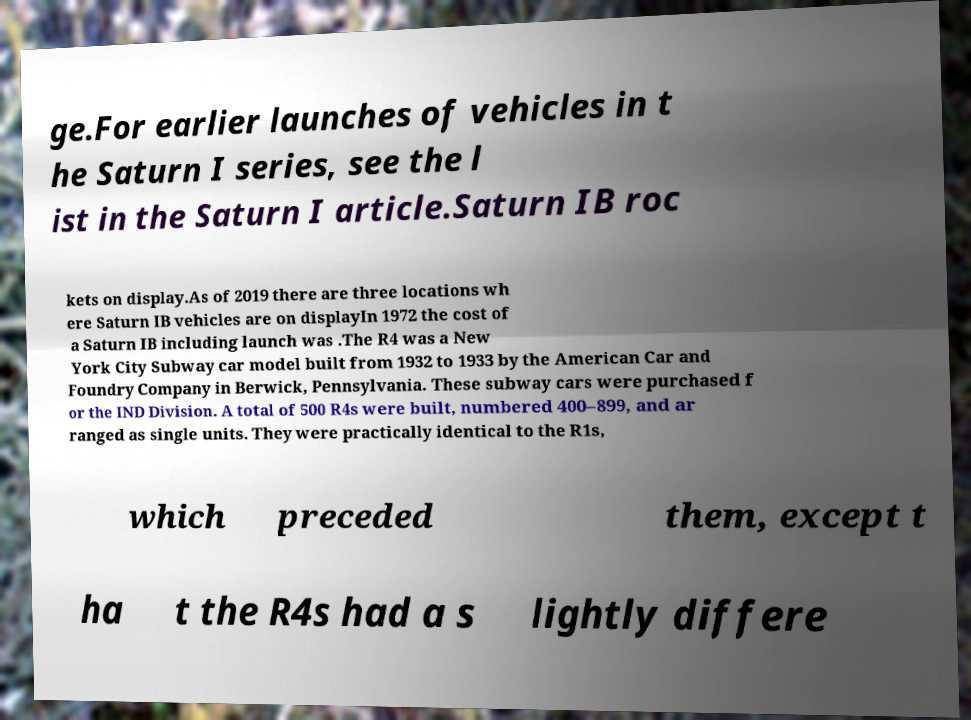Can you read and provide the text displayed in the image?This photo seems to have some interesting text. Can you extract and type it out for me? ge.For earlier launches of vehicles in t he Saturn I series, see the l ist in the Saturn I article.Saturn IB roc kets on display.As of 2019 there are three locations wh ere Saturn IB vehicles are on displayIn 1972 the cost of a Saturn IB including launch was .The R4 was a New York City Subway car model built from 1932 to 1933 by the American Car and Foundry Company in Berwick, Pennsylvania. These subway cars were purchased f or the IND Division. A total of 500 R4s were built, numbered 400–899, and ar ranged as single units. They were practically identical to the R1s, which preceded them, except t ha t the R4s had a s lightly differe 